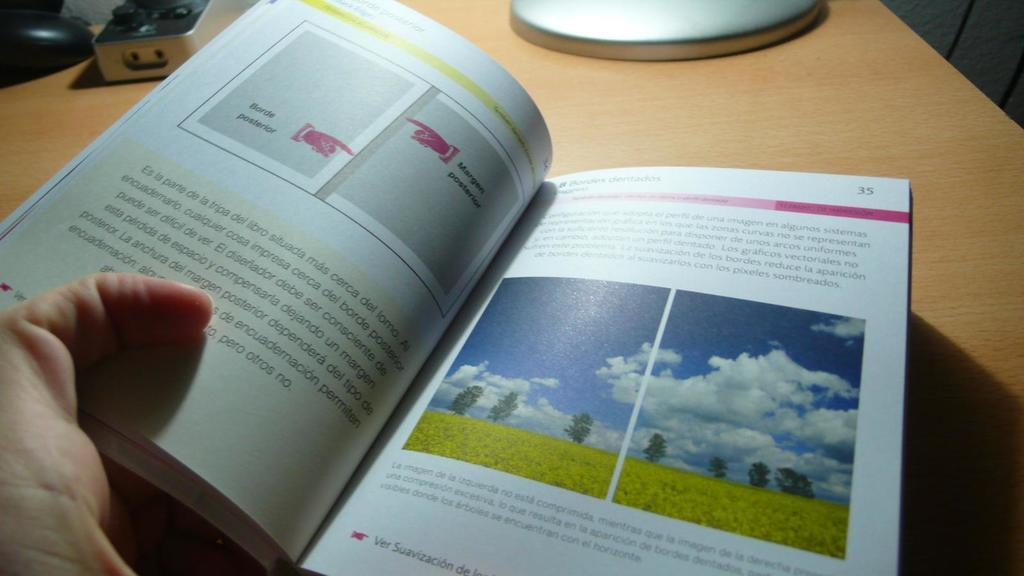Provide a one-sentence caption for the provided image. A booklet is opened to page number 35. 